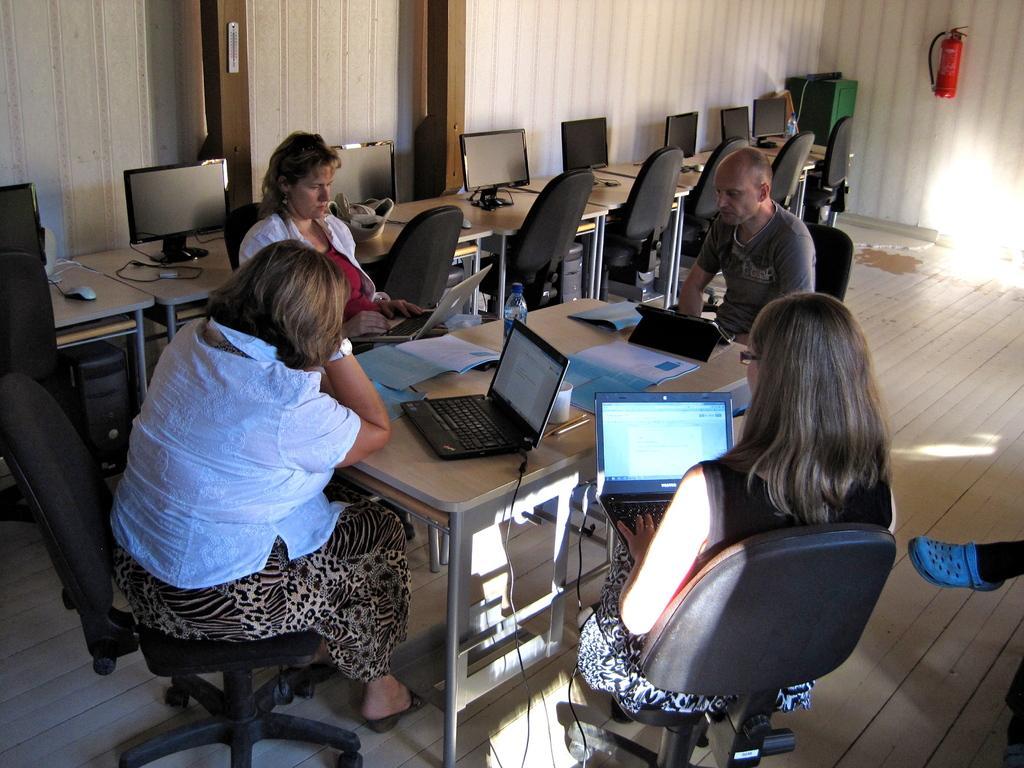Could you give a brief overview of what you see in this image? In a room there are three ladies and one man are sitting on a chairs. Two ladies are holding laptops in their hands. In between them there is a table with laptop, papers, water bottle and a cup on it. To the left corner there are table with monitors on it. Down the table there are many CPUs. To the right corner there is a fire extinguisher. 